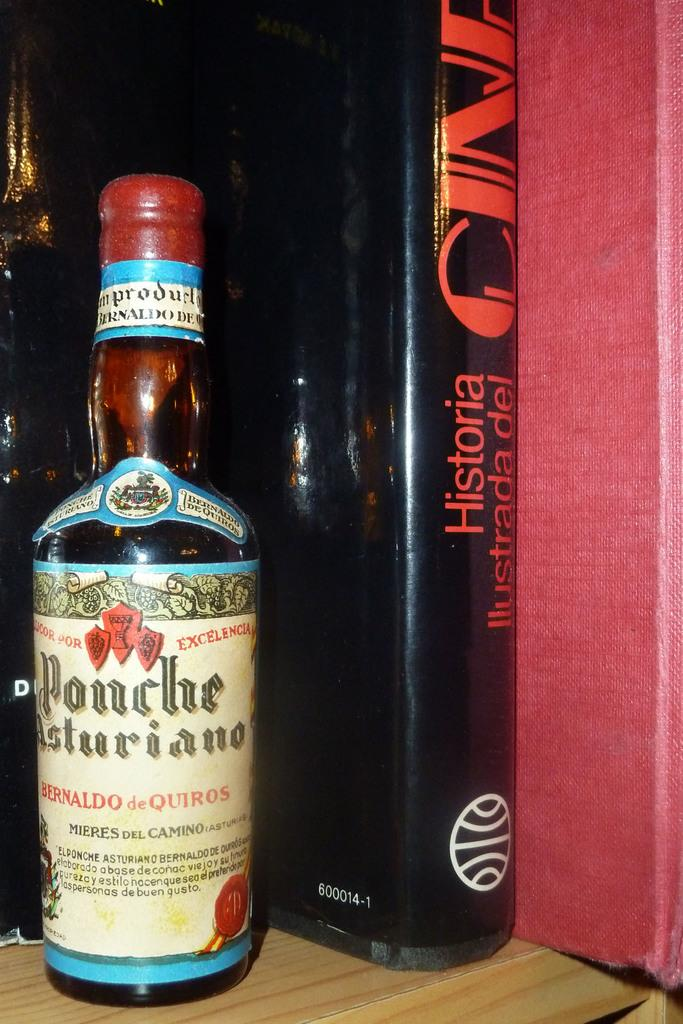Provide a one-sentence caption for the provided image. a Ponche Asturiano liqior bottle on the shelf with a book. 